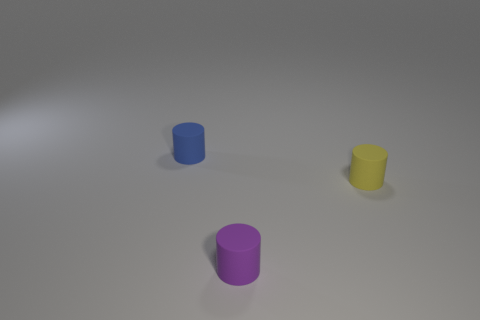Add 1 small purple cylinders. How many objects exist? 4 Subtract all blue cylinders. How many cylinders are left? 2 Subtract all purple cubes. How many blue cylinders are left? 1 Add 2 small cylinders. How many small cylinders exist? 5 Subtract 0 green spheres. How many objects are left? 3 Subtract all green cylinders. Subtract all yellow spheres. How many cylinders are left? 3 Subtract all small things. Subtract all tiny green metallic cylinders. How many objects are left? 0 Add 2 small objects. How many small objects are left? 5 